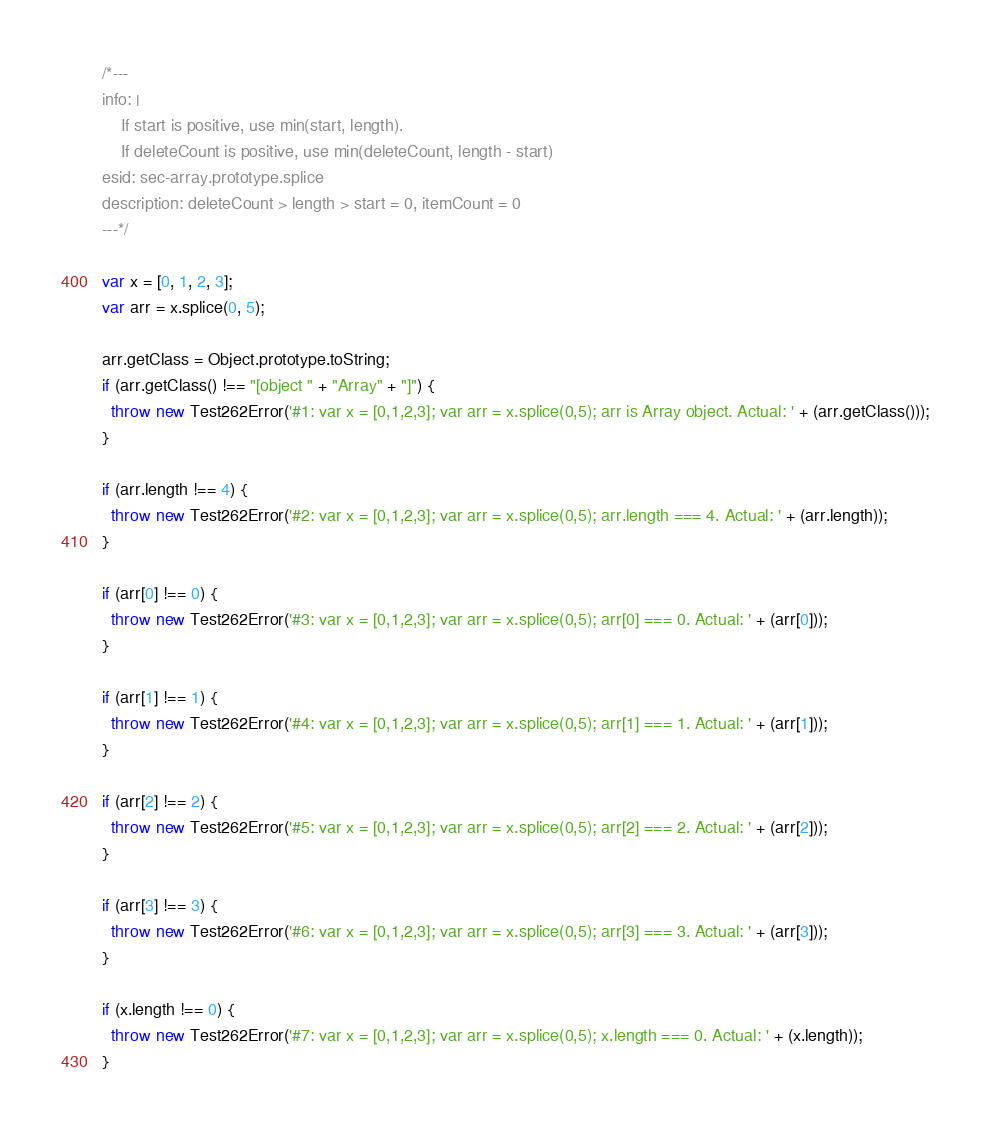Convert code to text. <code><loc_0><loc_0><loc_500><loc_500><_JavaScript_>/*---
info: |
    If start is positive, use min(start, length).
    If deleteCount is positive, use min(deleteCount, length - start)
esid: sec-array.prototype.splice
description: deleteCount > length > start = 0, itemCount = 0
---*/

var x = [0, 1, 2, 3];
var arr = x.splice(0, 5);

arr.getClass = Object.prototype.toString;
if (arr.getClass() !== "[object " + "Array" + "]") {
  throw new Test262Error('#1: var x = [0,1,2,3]; var arr = x.splice(0,5); arr is Array object. Actual: ' + (arr.getClass()));
}

if (arr.length !== 4) {
  throw new Test262Error('#2: var x = [0,1,2,3]; var arr = x.splice(0,5); arr.length === 4. Actual: ' + (arr.length));
}

if (arr[0] !== 0) {
  throw new Test262Error('#3: var x = [0,1,2,3]; var arr = x.splice(0,5); arr[0] === 0. Actual: ' + (arr[0]));
}

if (arr[1] !== 1) {
  throw new Test262Error('#4: var x = [0,1,2,3]; var arr = x.splice(0,5); arr[1] === 1. Actual: ' + (arr[1]));
}

if (arr[2] !== 2) {
  throw new Test262Error('#5: var x = [0,1,2,3]; var arr = x.splice(0,5); arr[2] === 2. Actual: ' + (arr[2]));
}

if (arr[3] !== 3) {
  throw new Test262Error('#6: var x = [0,1,2,3]; var arr = x.splice(0,5); arr[3] === 3. Actual: ' + (arr[3]));
}

if (x.length !== 0) {
  throw new Test262Error('#7: var x = [0,1,2,3]; var arr = x.splice(0,5); x.length === 0. Actual: ' + (x.length));
}
</code> 